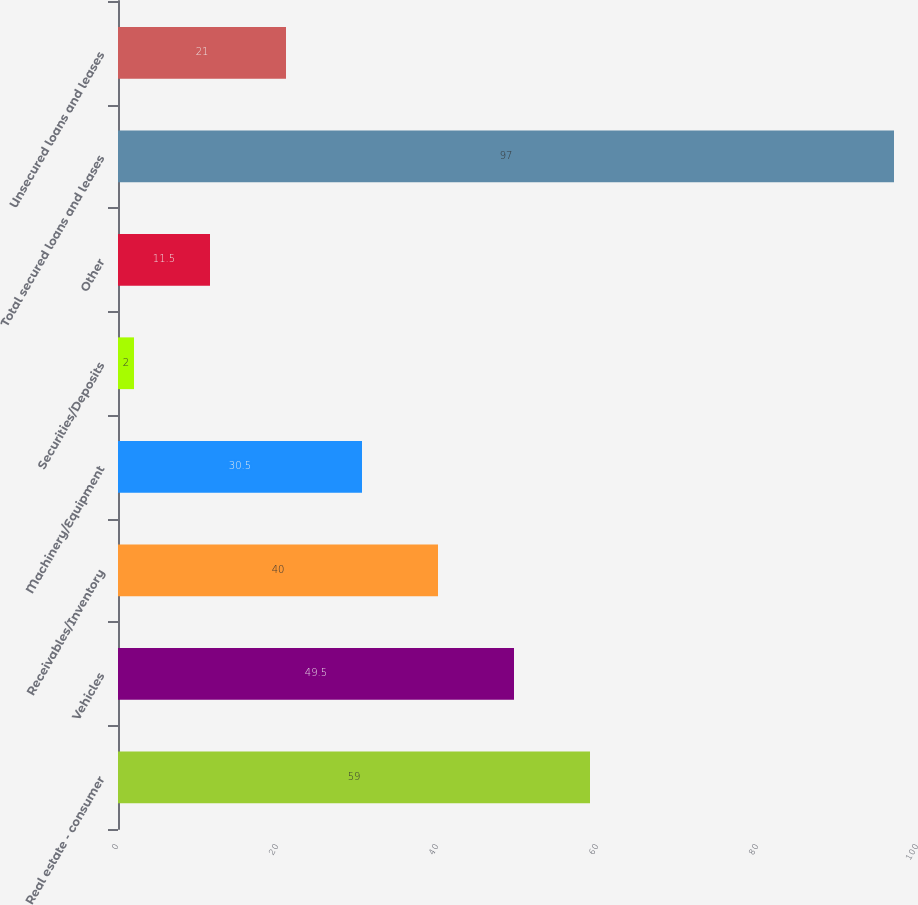<chart> <loc_0><loc_0><loc_500><loc_500><bar_chart><fcel>Real estate - consumer<fcel>Vehicles<fcel>Receivables/Inventory<fcel>Machinery/Equipment<fcel>Securities/Deposits<fcel>Other<fcel>Total secured loans and leases<fcel>Unsecured loans and leases<nl><fcel>59<fcel>49.5<fcel>40<fcel>30.5<fcel>2<fcel>11.5<fcel>97<fcel>21<nl></chart> 